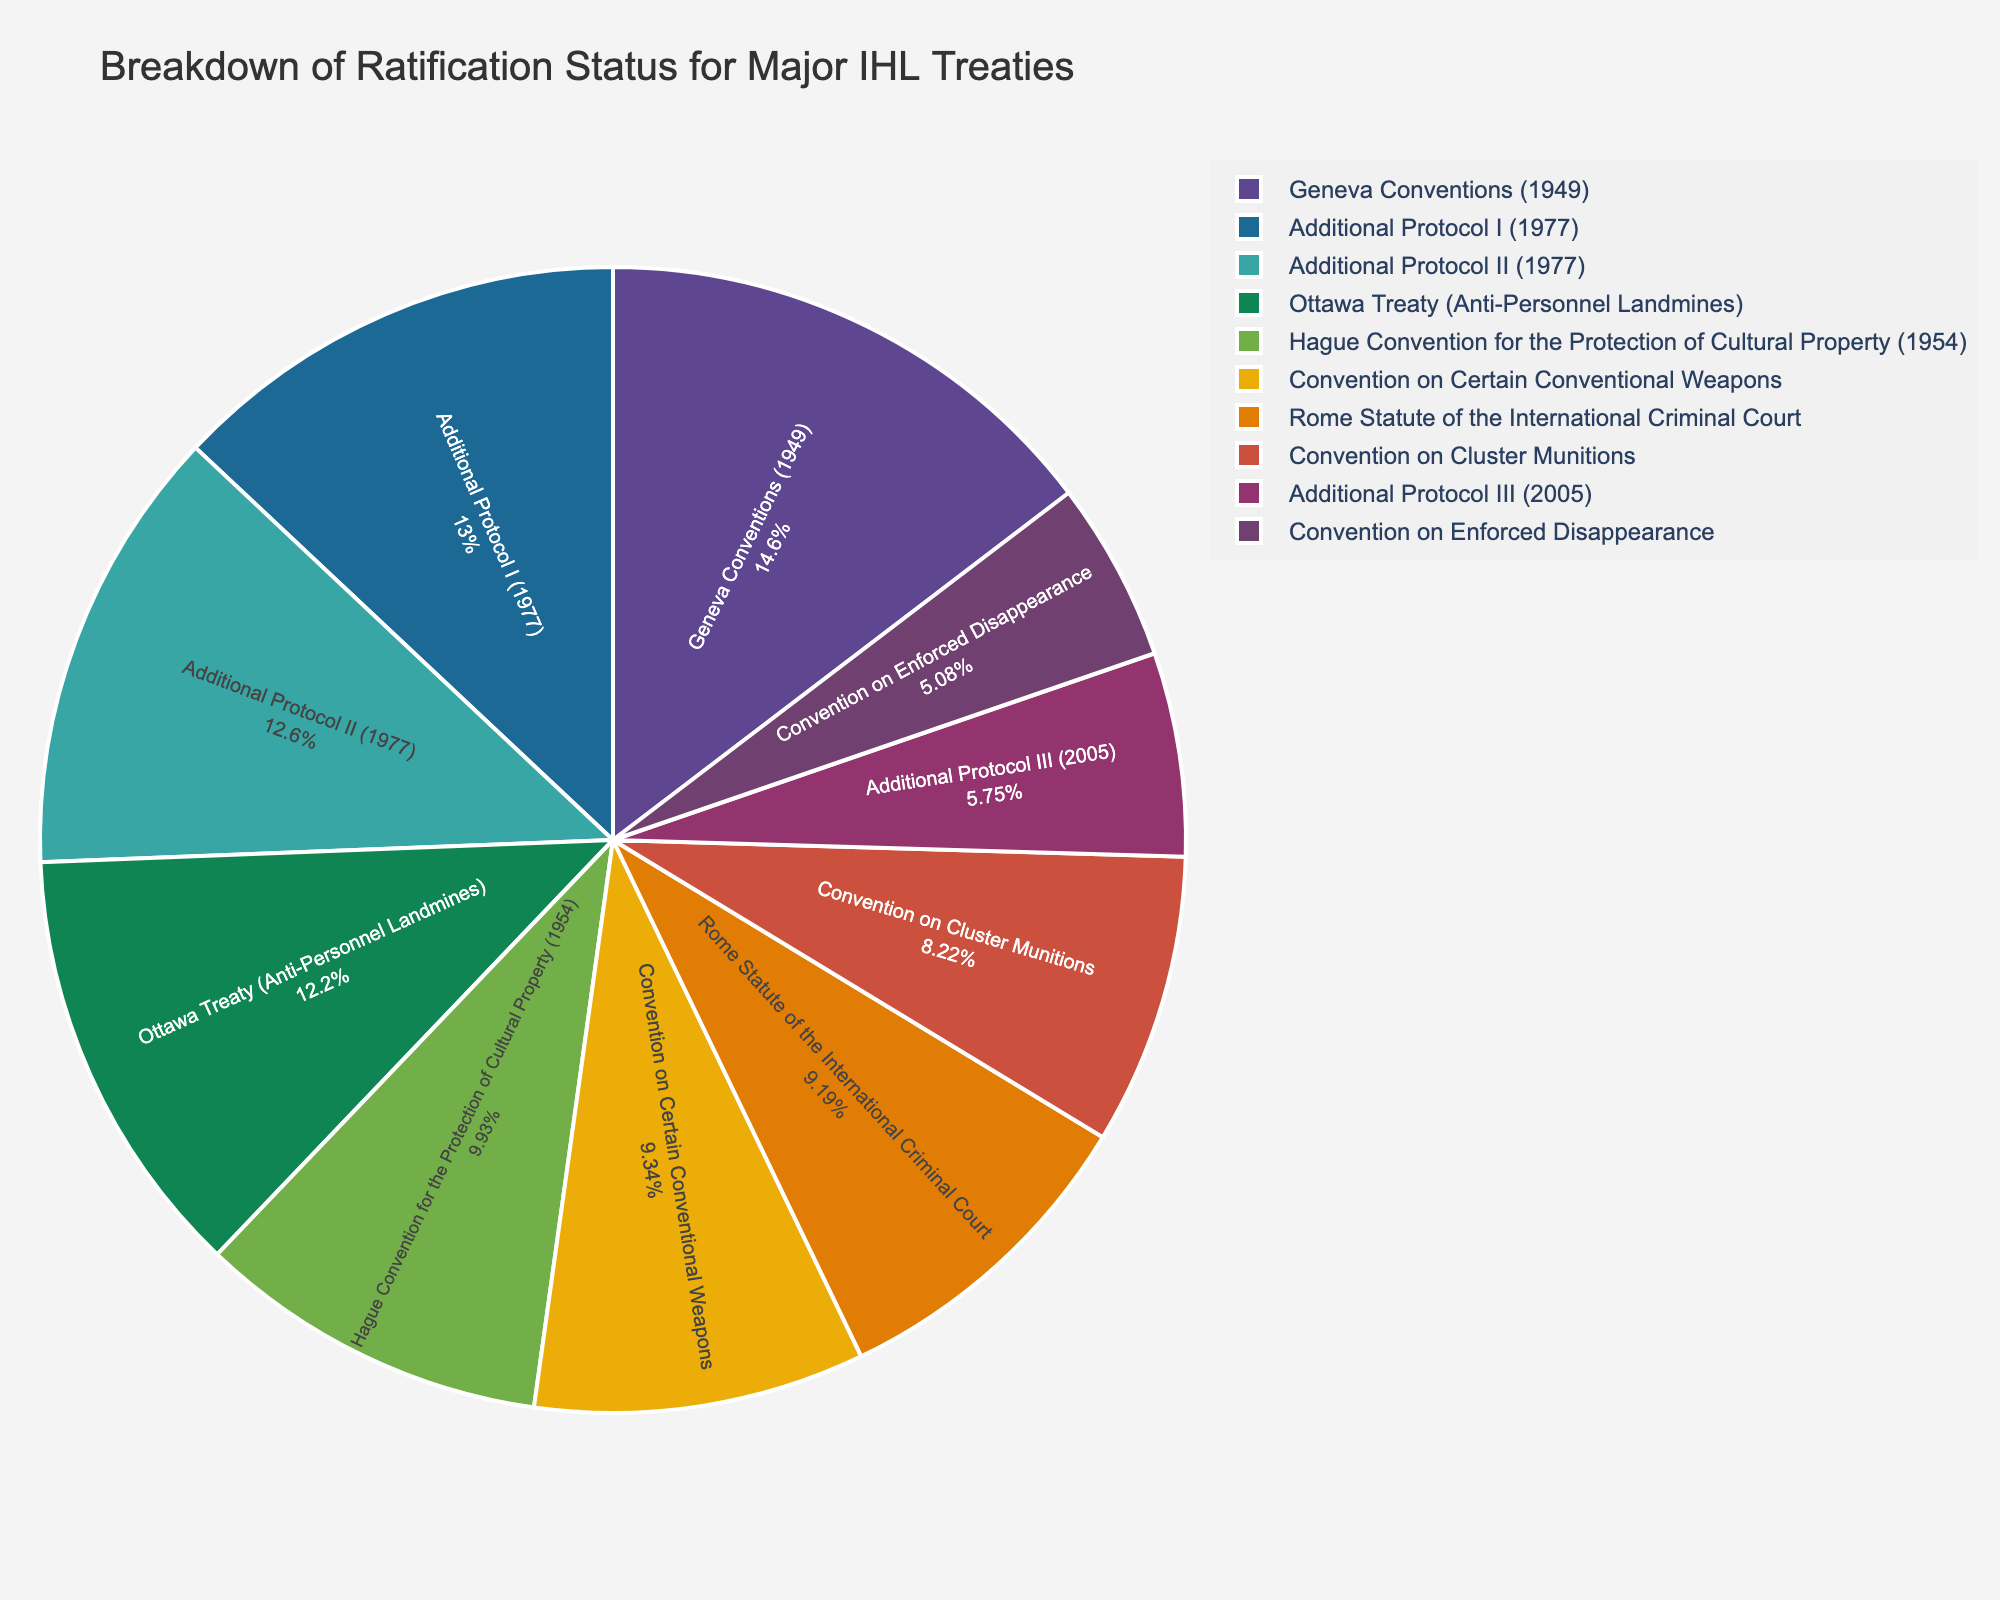What percentage of the total ratifications does the Geneva Conventions (1949) represent? To find the percentage, divide the number of ratifications for the Geneva Conventions (1949) by the total number of ratifications and multiply by 100. Sum up all ratifications: 196 + 174 + 169 + 77 + 133 + 164 + 110 + 123 + 125 + 68 = 1339. The percentage is (196/1339) * 100 ≈ 14.64%.
Answer: 14.64% Which treaty has the lowest number of ratifications? By inspecting the pie chart, the Convention on Enforced Disappearance has the smallest slice, indicating the lowest number of ratifications.
Answer: Convention on Enforced Disappearance Compare the ratifications of Additional Protocol I (1977) and Additional Protocol II (1977). Which has more, and by how much? Additional Protocol I (1977) has 174 ratifications, and Additional Protocol II (1977) has 169 ratifications. The difference is 174 - 169 = 5.
Answer: Additional Protocol I (1977) by 5 What is the combined percentage of ratifications for the Ottawa Treaty and the Convention on Cluster Munitions? Add the ratifications of both treaties: 164 + 110 = 274. Calculate the percentage: (274/1339) * 100 ≈ 20.47%.
Answer: 20.47% Which treaties have more than 150 ratifications each? From the pie chart, the treaties with more than 150 ratifications are Geneva Conventions (1949), Additional Protocol I (1977), Additional Protocol II (1977), and Ottawa Treaty (Anti-Personnel Landmines).
Answer: Geneva Conventions (1949), Additional Protocol I (1977), Additional Protocol II (1977), Ottawa Treaty (Anti-Personnel Landmines) What is the ratio of ratifications between the Hague Convention for the Protection of Cultural Property (1954) and the Additional Protocol III (2005)? The Hague Convention for the Protection of Cultural Property (1954) has 133 ratifications while Additional Protocol III (2005) has 77 ratifications. The ratio is 133:77, simplified to approximately 1.73:1.
Answer: 1.73:1 How do the total ratifications of the Additional Protocols compare to the Geneva Conventions (1949)? Sum the ratifications of the Additional Protocols: 174 + 169 + 77 = 420. Compare it with the Geneva Conventions (1949) which has 196 ratifications. 420 is more than 196 by 224.
Answer: Additional Protocols by 224 By how much does the number of ratifications for the Rome Statute of the International Criminal Court exceed those for the Convention on Certain Conventional Weapons? The Rome Statute has 123 ratifications, and the Convention on Certain Conventional Weapons has 125 ratifications. 125 - 123 = 2.
Answer: Convention on Certain Conventional Weapons by 2 Which color in the pie chart represents the Hague Convention for the Protection of Cultural Property (1954)? In the pie chart generated, the specific color for each treaty can be visually identified. The slice with 133 ratifications representing the Hague Convention for the Protection of Cultural Property (1954) would appear in its unique color, which needs to be checked visually.
Answer: Check the color visually What is the average number of ratifications across all major IHL treaties listed? Sum the total number of ratifications: 1339. Since there are 10 treaties, the average is 1339 / 10 = 133.9.
Answer: 133.9 